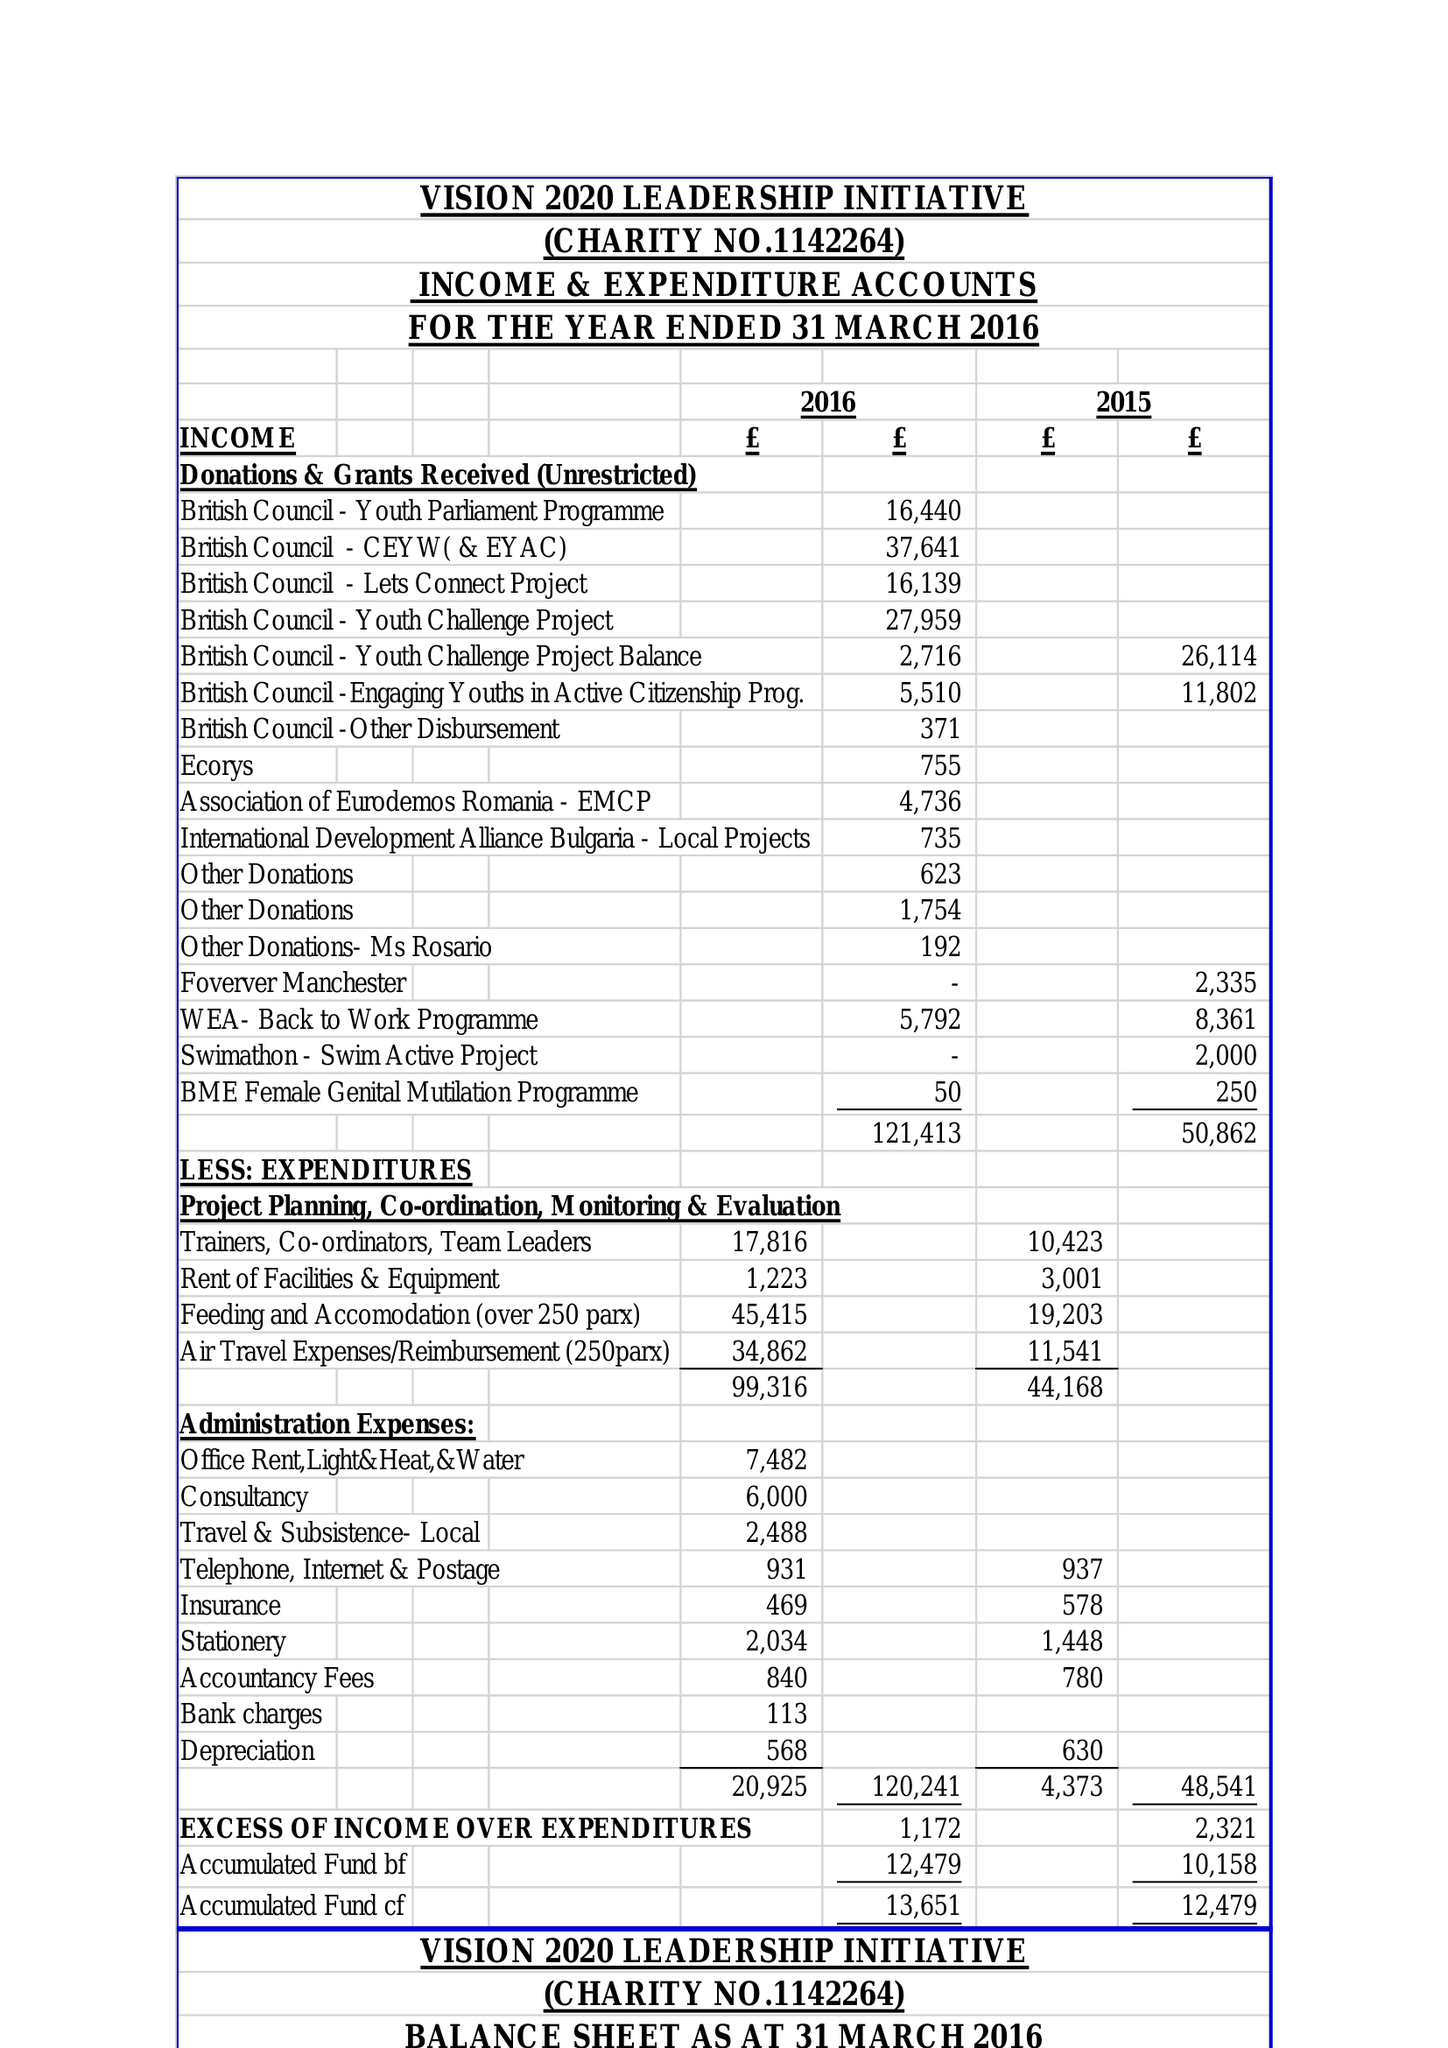What is the value for the charity_name?
Answer the question using a single word or phrase. Vision 2020 Leadership Initiative 